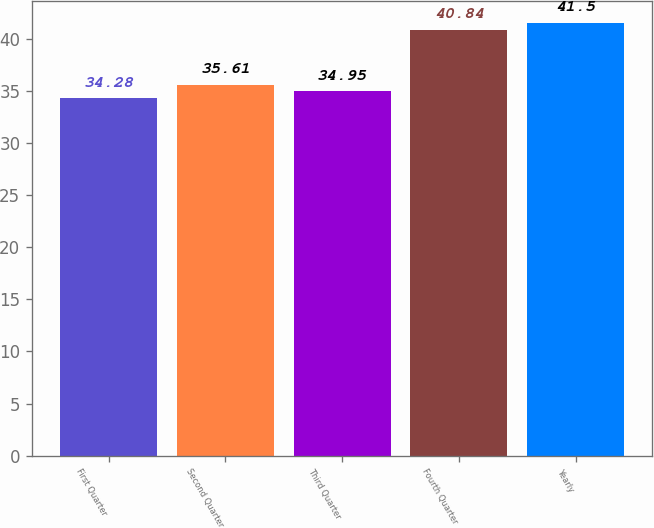Convert chart to OTSL. <chart><loc_0><loc_0><loc_500><loc_500><bar_chart><fcel>First Quarter<fcel>Second Quarter<fcel>Third Quarter<fcel>Fourth Quarter<fcel>Yearly<nl><fcel>34.28<fcel>35.61<fcel>34.95<fcel>40.84<fcel>41.5<nl></chart> 